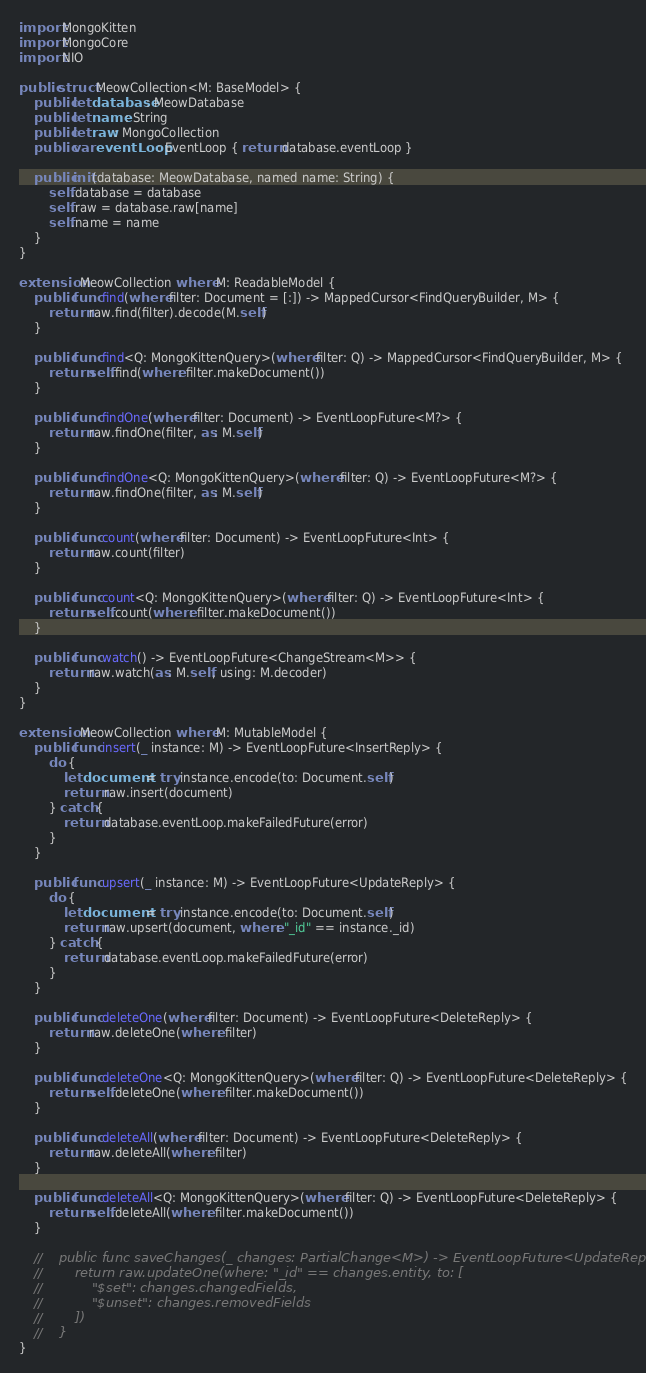<code> <loc_0><loc_0><loc_500><loc_500><_Swift_>import MongoKitten
import MongoCore
import NIO

public struct MeowCollection<M: BaseModel> {
    public let database: MeowDatabase
    public let name: String
    public let raw: MongoCollection
    public var eventLoop: EventLoop { return database.eventLoop }
    
    public init(database: MeowDatabase, named name: String) {
        self.database = database
        self.raw = database.raw[name]
        self.name = name
    }
}

extension MeowCollection where M: ReadableModel {
    public func find(where filter: Document = [:]) -> MappedCursor<FindQueryBuilder, M> {
        return raw.find(filter).decode(M.self)
    }
    
    public func find<Q: MongoKittenQuery>(where filter: Q) -> MappedCursor<FindQueryBuilder, M> {
        return self.find(where: filter.makeDocument())
    }
    
    public func findOne(where filter: Document) -> EventLoopFuture<M?> {
        return raw.findOne(filter, as: M.self)
    }
    
    public func findOne<Q: MongoKittenQuery>(where filter: Q) -> EventLoopFuture<M?> {
        return raw.findOne(filter, as: M.self)
    }
    
    public func count(where filter: Document) -> EventLoopFuture<Int> {
        return raw.count(filter)
    }
    
    public func count<Q: MongoKittenQuery>(where filter: Q) -> EventLoopFuture<Int> {
        return self.count(where: filter.makeDocument())
    }
    
    public func watch() -> EventLoopFuture<ChangeStream<M>> {
        return raw.watch(as: M.self, using: M.decoder)
    }
}

extension MeowCollection where M: MutableModel {
    public func insert(_ instance: M) -> EventLoopFuture<InsertReply> {
        do {
            let document = try instance.encode(to: Document.self)
            return raw.insert(document)
        } catch {
            return database.eventLoop.makeFailedFuture(error)
        }
    }
    
    public func upsert(_ instance: M) -> EventLoopFuture<UpdateReply> {
        do {
            let document = try instance.encode(to: Document.self)
            return raw.upsert(document, where: "_id" == instance._id)
        } catch {
            return database.eventLoop.makeFailedFuture(error)
        }
    }
    
    public func deleteOne(where filter: Document) -> EventLoopFuture<DeleteReply> {
        return raw.deleteOne(where: filter)
    }
    
    public func deleteOne<Q: MongoKittenQuery>(where filter: Q) -> EventLoopFuture<DeleteReply> {
        return self.deleteOne(where: filter.makeDocument())
    }
    
    public func deleteAll(where filter: Document) -> EventLoopFuture<DeleteReply> {
        return raw.deleteAll(where: filter)
    }
    
    public func deleteAll<Q: MongoKittenQuery>(where filter: Q) -> EventLoopFuture<DeleteReply> {
        return self.deleteAll(where: filter.makeDocument())
    }
    
    //    public func saveChanges(_ changes: PartialChange<M>) -> EventLoopFuture<UpdateReply> {
    //        return raw.updateOne(where: "_id" == changes.entity, to: [
    //            "$set": changes.changedFields,
    //            "$unset": changes.removedFields
    //        ])
    //    }
}
</code> 